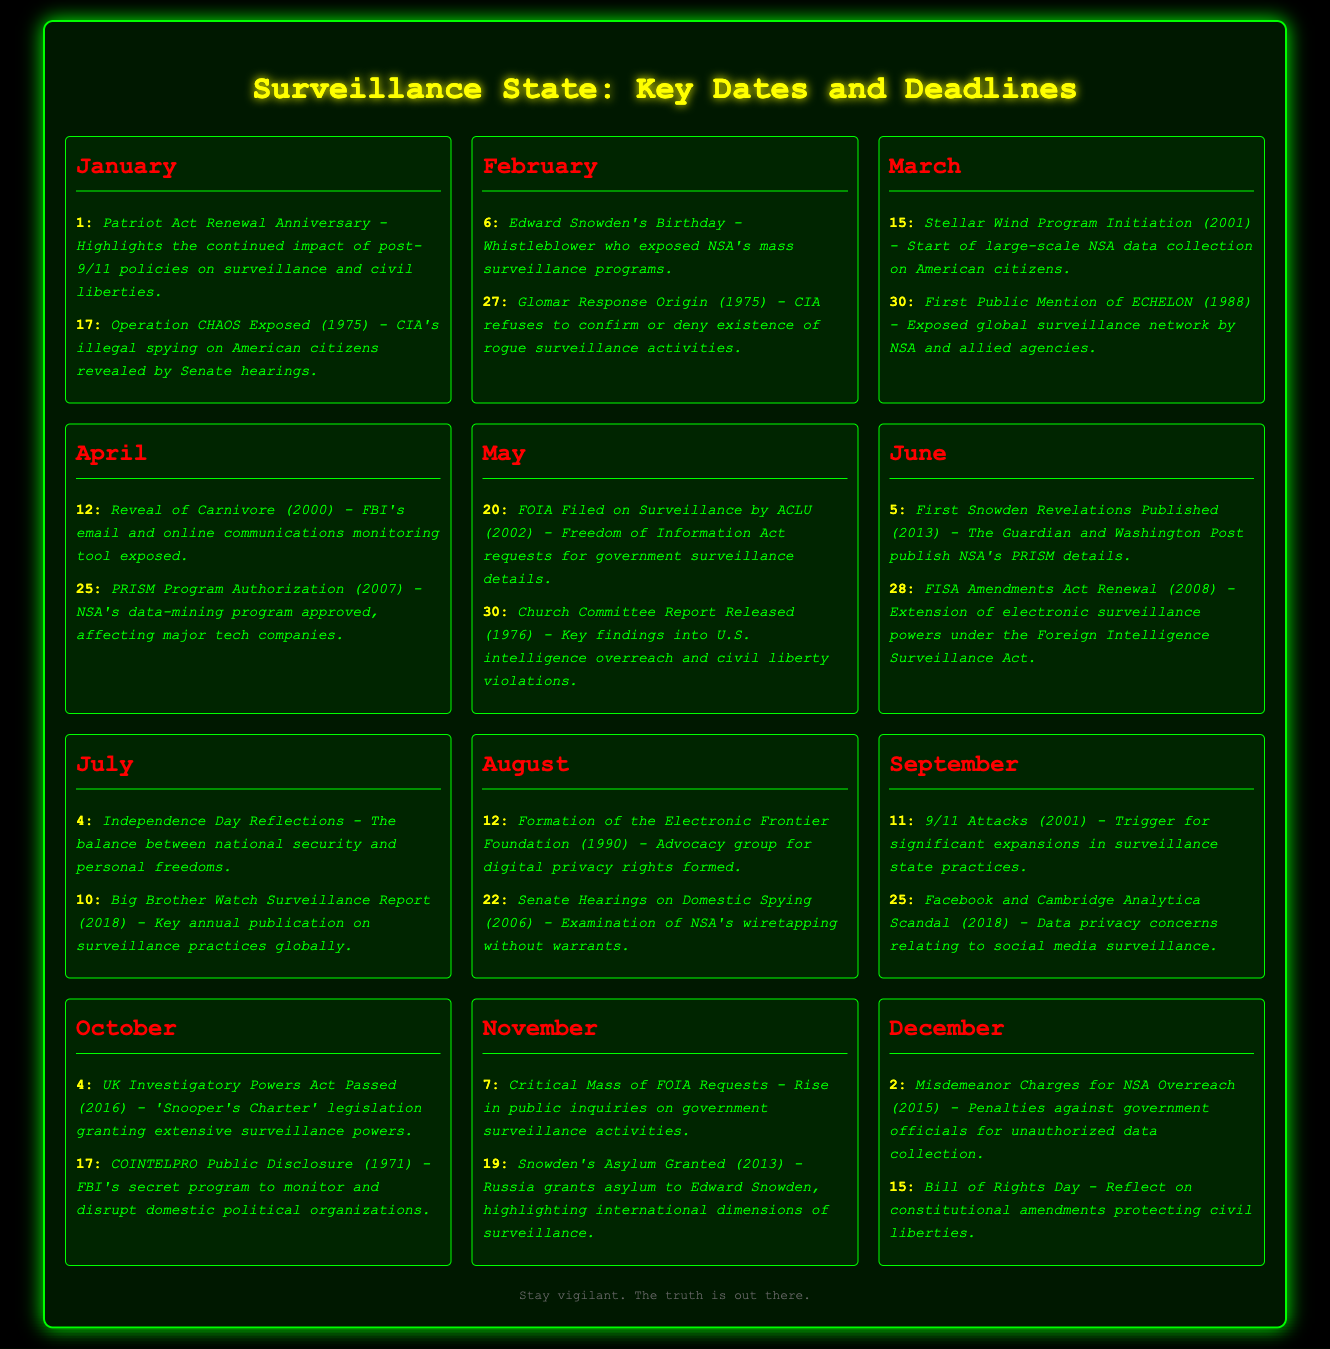What event is marked on January 1? This date marks the anniversary of the Patriot Act Renewal, highlighting its impact on surveillance and civil liberties.
Answer: Patriot Act Renewal Anniversary What was revealed on April 12, 2000? The event on this date is the reveal of Carnivore, an FBI tool for monitoring email and online communications.
Answer: Reveal of Carnivore How many events are documented in June? The document lists two events occurring in June, including Snowden's revelations and FISA amendments.
Answer: 2 Which month highlights the consequences of 9/11? The month of September discusses the implications of the September 11 attacks on the surveillance state.
Answer: September What's special about May 30, 1976? This date marks the release of the Church Committee Report, addressing U.S. intelligence overreach and civil liberties.
Answer: Church Committee Report Released 